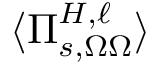Convert formula to latex. <formula><loc_0><loc_0><loc_500><loc_500>\langle \Pi _ { s , \Omega \Omega } ^ { H , \ell } \rangle</formula> 